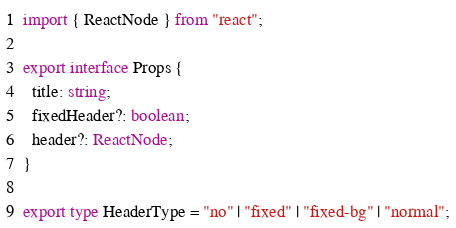<code> <loc_0><loc_0><loc_500><loc_500><_TypeScript_>import { ReactNode } from "react";

export interface Props {
  title: string;
  fixedHeader?: boolean;
  header?: ReactNode;
}

export type HeaderType = "no" | "fixed" | "fixed-bg" | "normal";
</code> 